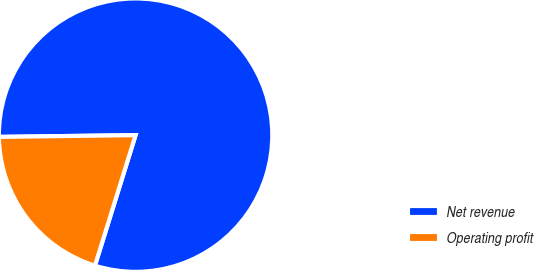Convert chart to OTSL. <chart><loc_0><loc_0><loc_500><loc_500><pie_chart><fcel>Net revenue<fcel>Operating profit<nl><fcel>80.01%<fcel>19.99%<nl></chart> 